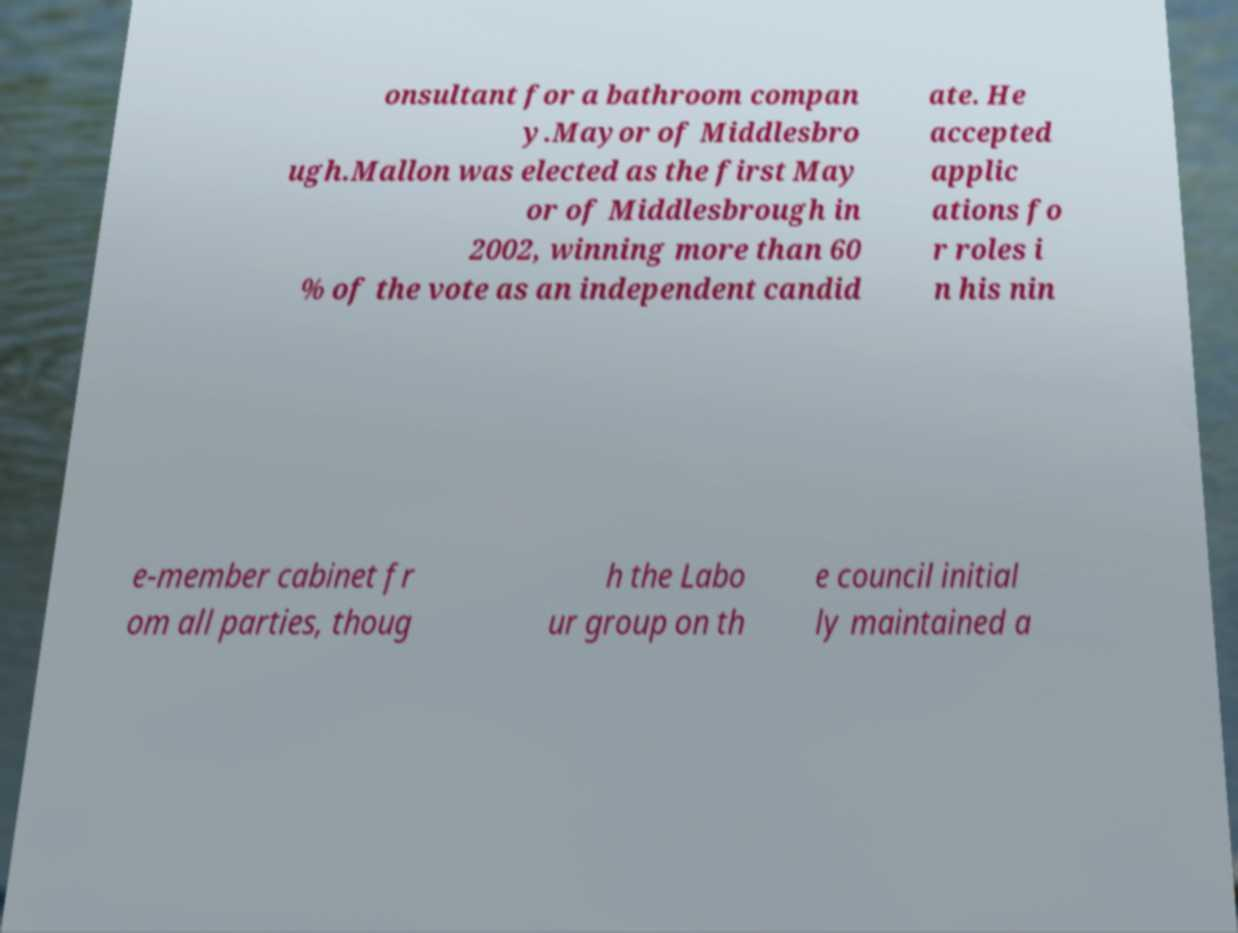Could you assist in decoding the text presented in this image and type it out clearly? onsultant for a bathroom compan y.Mayor of Middlesbro ugh.Mallon was elected as the first May or of Middlesbrough in 2002, winning more than 60 % of the vote as an independent candid ate. He accepted applic ations fo r roles i n his nin e-member cabinet fr om all parties, thoug h the Labo ur group on th e council initial ly maintained a 